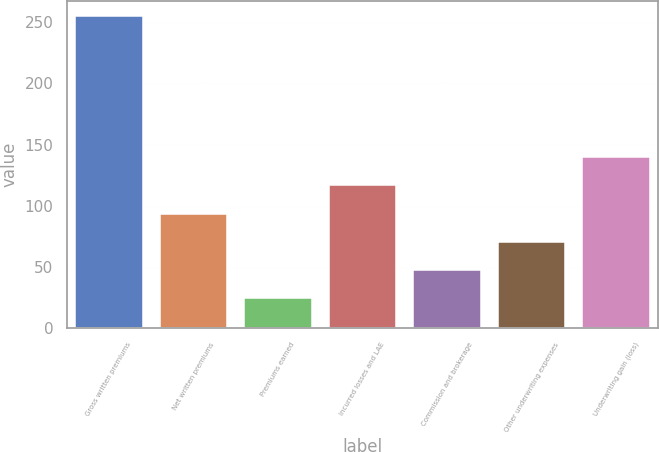Convert chart. <chart><loc_0><loc_0><loc_500><loc_500><bar_chart><fcel>Gross written premiums<fcel>Net written premiums<fcel>Premiums earned<fcel>Incurred losses and LAE<fcel>Commission and brokerage<fcel>Other underwriting expenses<fcel>Underwriting gain (loss)<nl><fcel>254.7<fcel>93.63<fcel>24.6<fcel>116.64<fcel>47.61<fcel>70.62<fcel>139.65<nl></chart> 